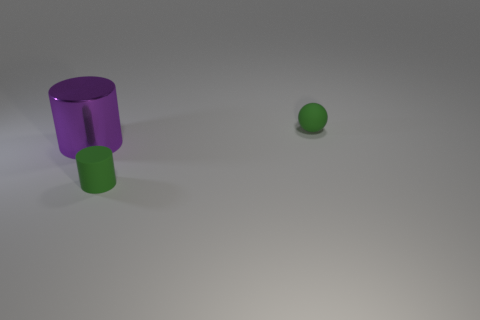What is the color of the tiny object that is the same shape as the large purple metallic object?
Your response must be concise. Green. Is there another tiny thing that has the same shape as the shiny object?
Your answer should be compact. Yes. How many other objects are there of the same size as the metal cylinder?
Offer a terse response. 0. There is a thing that is behind the tiny rubber cylinder and in front of the rubber ball; what material is it?
Keep it short and to the point. Metal. There is a thing that is left of the small green matte cylinder; does it have the same shape as the tiny green thing that is in front of the big metal cylinder?
Give a very brief answer. Yes. Is there any other thing that has the same material as the large purple cylinder?
Keep it short and to the point. No. There is a object left of the matte object that is on the left side of the tiny rubber object that is on the right side of the green cylinder; what is its shape?
Give a very brief answer. Cylinder. What number of other objects are there of the same shape as the purple object?
Offer a terse response. 1. How many cylinders are either metallic things or small rubber things?
Offer a terse response. 2. What number of big shiny cylinders are there?
Your answer should be very brief. 1. 